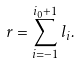Convert formula to latex. <formula><loc_0><loc_0><loc_500><loc_500>r = \sum _ { i = - 1 } ^ { i _ { 0 } + 1 } l _ { i } .</formula> 